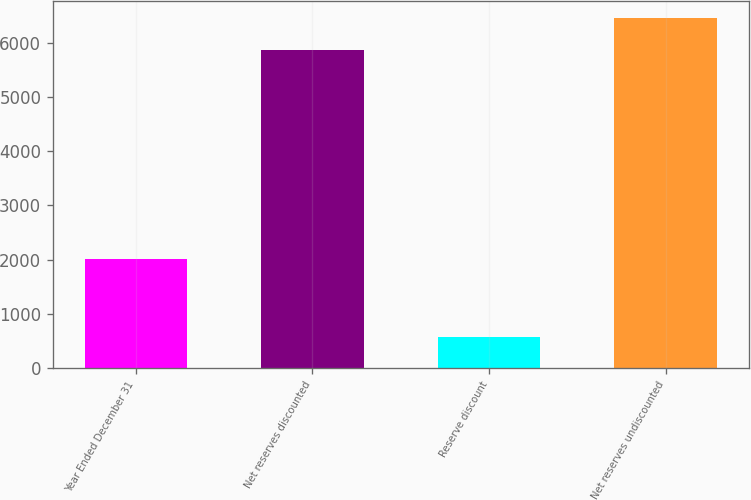<chart> <loc_0><loc_0><loc_500><loc_500><bar_chart><fcel>Year Ended December 31<fcel>Net reserves discounted<fcel>Reserve discount<fcel>Net reserves undiscounted<nl><fcel>2005<fcel>5867<fcel>575<fcel>6453.7<nl></chart> 